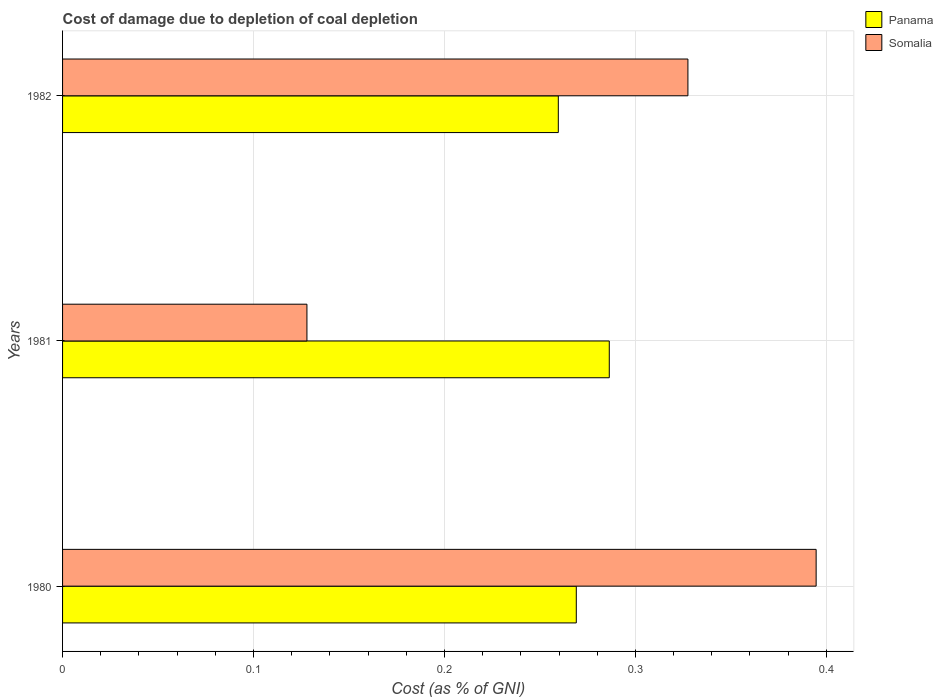How many groups of bars are there?
Provide a short and direct response. 3. Are the number of bars on each tick of the Y-axis equal?
Give a very brief answer. Yes. In how many cases, is the number of bars for a given year not equal to the number of legend labels?
Give a very brief answer. 0. What is the cost of damage caused due to coal depletion in Somalia in 1981?
Your answer should be compact. 0.13. Across all years, what is the maximum cost of damage caused due to coal depletion in Somalia?
Make the answer very short. 0.39. Across all years, what is the minimum cost of damage caused due to coal depletion in Somalia?
Your answer should be very brief. 0.13. In which year was the cost of damage caused due to coal depletion in Panama minimum?
Your answer should be very brief. 1982. What is the total cost of damage caused due to coal depletion in Panama in the graph?
Ensure brevity in your answer.  0.81. What is the difference between the cost of damage caused due to coal depletion in Panama in 1980 and that in 1981?
Provide a short and direct response. -0.02. What is the difference between the cost of damage caused due to coal depletion in Somalia in 1981 and the cost of damage caused due to coal depletion in Panama in 1980?
Your answer should be very brief. -0.14. What is the average cost of damage caused due to coal depletion in Panama per year?
Give a very brief answer. 0.27. In the year 1980, what is the difference between the cost of damage caused due to coal depletion in Somalia and cost of damage caused due to coal depletion in Panama?
Your answer should be compact. 0.13. What is the ratio of the cost of damage caused due to coal depletion in Somalia in 1980 to that in 1981?
Make the answer very short. 3.08. What is the difference between the highest and the second highest cost of damage caused due to coal depletion in Panama?
Make the answer very short. 0.02. What is the difference between the highest and the lowest cost of damage caused due to coal depletion in Somalia?
Keep it short and to the point. 0.27. Is the sum of the cost of damage caused due to coal depletion in Panama in 1981 and 1982 greater than the maximum cost of damage caused due to coal depletion in Somalia across all years?
Make the answer very short. Yes. What does the 2nd bar from the top in 1981 represents?
Your answer should be compact. Panama. What does the 2nd bar from the bottom in 1981 represents?
Ensure brevity in your answer.  Somalia. How many bars are there?
Make the answer very short. 6. Are all the bars in the graph horizontal?
Offer a terse response. Yes. Does the graph contain grids?
Keep it short and to the point. Yes. How are the legend labels stacked?
Your answer should be compact. Vertical. What is the title of the graph?
Keep it short and to the point. Cost of damage due to depletion of coal depletion. What is the label or title of the X-axis?
Your response must be concise. Cost (as % of GNI). What is the Cost (as % of GNI) in Panama in 1980?
Your answer should be very brief. 0.27. What is the Cost (as % of GNI) in Somalia in 1980?
Give a very brief answer. 0.39. What is the Cost (as % of GNI) in Panama in 1981?
Give a very brief answer. 0.29. What is the Cost (as % of GNI) of Somalia in 1981?
Offer a terse response. 0.13. What is the Cost (as % of GNI) in Panama in 1982?
Your answer should be compact. 0.26. What is the Cost (as % of GNI) of Somalia in 1982?
Keep it short and to the point. 0.33. Across all years, what is the maximum Cost (as % of GNI) in Panama?
Provide a short and direct response. 0.29. Across all years, what is the maximum Cost (as % of GNI) of Somalia?
Your answer should be compact. 0.39. Across all years, what is the minimum Cost (as % of GNI) in Panama?
Offer a very short reply. 0.26. Across all years, what is the minimum Cost (as % of GNI) of Somalia?
Provide a succinct answer. 0.13. What is the total Cost (as % of GNI) of Panama in the graph?
Make the answer very short. 0.81. What is the total Cost (as % of GNI) in Somalia in the graph?
Make the answer very short. 0.85. What is the difference between the Cost (as % of GNI) of Panama in 1980 and that in 1981?
Give a very brief answer. -0.02. What is the difference between the Cost (as % of GNI) in Somalia in 1980 and that in 1981?
Make the answer very short. 0.27. What is the difference between the Cost (as % of GNI) in Panama in 1980 and that in 1982?
Offer a very short reply. 0.01. What is the difference between the Cost (as % of GNI) of Somalia in 1980 and that in 1982?
Keep it short and to the point. 0.07. What is the difference between the Cost (as % of GNI) in Panama in 1981 and that in 1982?
Provide a succinct answer. 0.03. What is the difference between the Cost (as % of GNI) of Somalia in 1981 and that in 1982?
Keep it short and to the point. -0.2. What is the difference between the Cost (as % of GNI) of Panama in 1980 and the Cost (as % of GNI) of Somalia in 1981?
Provide a succinct answer. 0.14. What is the difference between the Cost (as % of GNI) of Panama in 1980 and the Cost (as % of GNI) of Somalia in 1982?
Your response must be concise. -0.06. What is the difference between the Cost (as % of GNI) of Panama in 1981 and the Cost (as % of GNI) of Somalia in 1982?
Your answer should be very brief. -0.04. What is the average Cost (as % of GNI) in Panama per year?
Your answer should be compact. 0.27. What is the average Cost (as % of GNI) of Somalia per year?
Offer a terse response. 0.28. In the year 1980, what is the difference between the Cost (as % of GNI) in Panama and Cost (as % of GNI) in Somalia?
Give a very brief answer. -0.13. In the year 1981, what is the difference between the Cost (as % of GNI) of Panama and Cost (as % of GNI) of Somalia?
Ensure brevity in your answer.  0.16. In the year 1982, what is the difference between the Cost (as % of GNI) in Panama and Cost (as % of GNI) in Somalia?
Keep it short and to the point. -0.07. What is the ratio of the Cost (as % of GNI) of Panama in 1980 to that in 1981?
Ensure brevity in your answer.  0.94. What is the ratio of the Cost (as % of GNI) in Somalia in 1980 to that in 1981?
Make the answer very short. 3.08. What is the ratio of the Cost (as % of GNI) in Panama in 1980 to that in 1982?
Your response must be concise. 1.04. What is the ratio of the Cost (as % of GNI) of Somalia in 1980 to that in 1982?
Make the answer very short. 1.21. What is the ratio of the Cost (as % of GNI) in Panama in 1981 to that in 1982?
Your answer should be compact. 1.1. What is the ratio of the Cost (as % of GNI) in Somalia in 1981 to that in 1982?
Keep it short and to the point. 0.39. What is the difference between the highest and the second highest Cost (as % of GNI) in Panama?
Provide a succinct answer. 0.02. What is the difference between the highest and the second highest Cost (as % of GNI) in Somalia?
Give a very brief answer. 0.07. What is the difference between the highest and the lowest Cost (as % of GNI) in Panama?
Keep it short and to the point. 0.03. What is the difference between the highest and the lowest Cost (as % of GNI) in Somalia?
Make the answer very short. 0.27. 